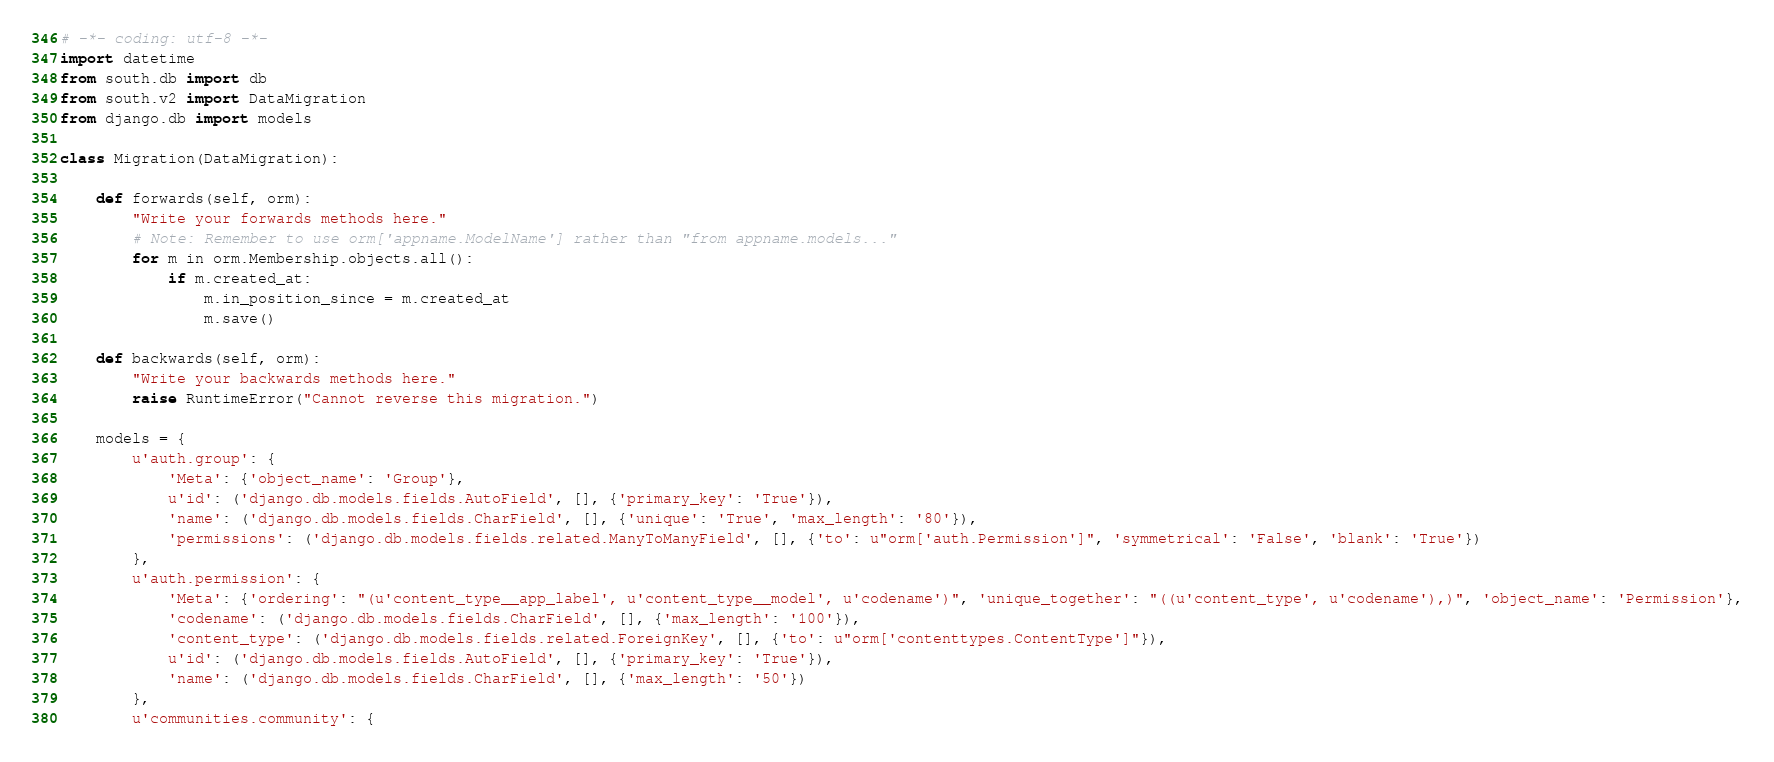<code> <loc_0><loc_0><loc_500><loc_500><_Python_># -*- coding: utf-8 -*-
import datetime
from south.db import db
from south.v2 import DataMigration
from django.db import models

class Migration(DataMigration):

    def forwards(self, orm):
        "Write your forwards methods here."
        # Note: Remember to use orm['appname.ModelName'] rather than "from appname.models..."
        for m in orm.Membership.objects.all():
            if m.created_at:
                m.in_position_since = m.created_at
                m.save()

    def backwards(self, orm):
        "Write your backwards methods here."
        raise RuntimeError("Cannot reverse this migration.")     

    models = {
        u'auth.group': {
            'Meta': {'object_name': 'Group'},
            u'id': ('django.db.models.fields.AutoField', [], {'primary_key': 'True'}),
            'name': ('django.db.models.fields.CharField', [], {'unique': 'True', 'max_length': '80'}),
            'permissions': ('django.db.models.fields.related.ManyToManyField', [], {'to': u"orm['auth.Permission']", 'symmetrical': 'False', 'blank': 'True'})
        },
        u'auth.permission': {
            'Meta': {'ordering': "(u'content_type__app_label', u'content_type__model', u'codename')", 'unique_together': "((u'content_type', u'codename'),)", 'object_name': 'Permission'},
            'codename': ('django.db.models.fields.CharField', [], {'max_length': '100'}),
            'content_type': ('django.db.models.fields.related.ForeignKey', [], {'to': u"orm['contenttypes.ContentType']"}),
            u'id': ('django.db.models.fields.AutoField', [], {'primary_key': 'True'}),
            'name': ('django.db.models.fields.CharField', [], {'max_length': '50'})
        },
        u'communities.community': {</code> 